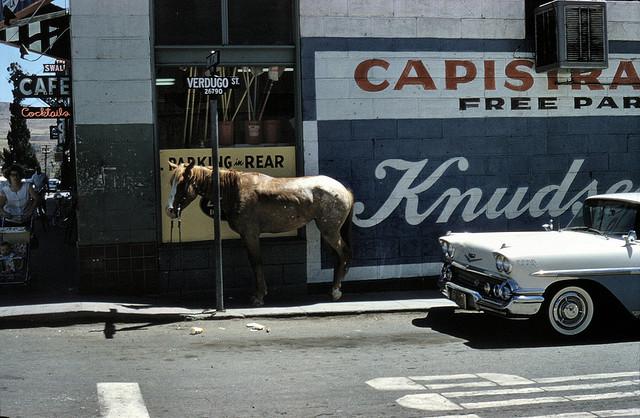Is that an old car?
Concise answer only. Yes. Is there an animal in the picture?
Be succinct. Yes. How much does it cost to park?
Keep it brief. Free. 